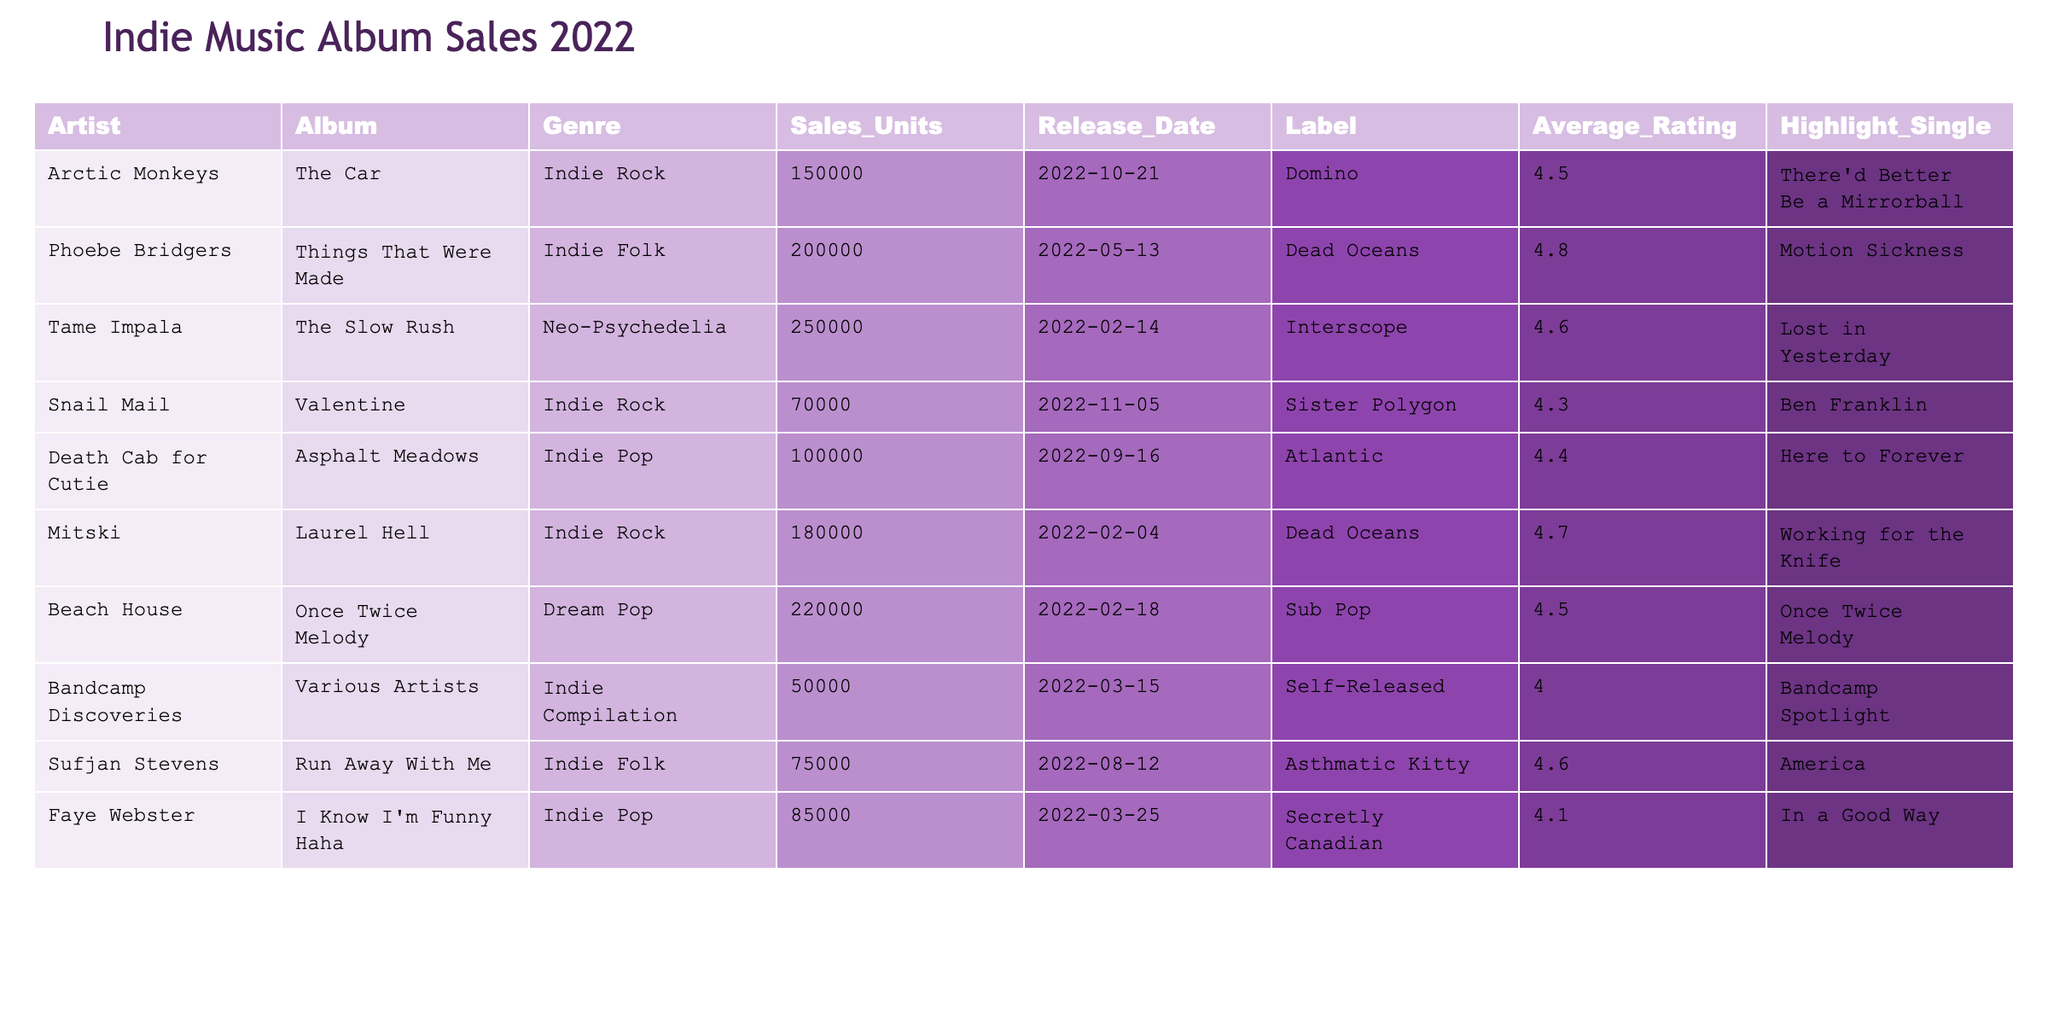What is the total number of sales units for Indie Rock albums? The table shows three Indie Rock albums: "The Car" with 150,000 units, "Valentine" with 70,000 units, and "Laurel Hell" with 180,000 units. To find the total, we add these values: 150,000 + 70,000 + 180,000 = 400,000.
Answer: 400,000 Which album had the highest average rating? The albums are ranked by their average ratings: "Things That Were Made" (4.8), "Laurel Hell" (4.7), "Run Away With Me" (4.6), and so forth. "Things That Were Made" has the highest average rating of 4.8.
Answer: Things That Were Made How many albums were released in 2022? All entries in the table indicate they were released in 2022. Thus, there are a total of 8 albums listed.
Answer: 8 Which genre had the most sales units? To determine this, we need to sum sales units for each genre: Indie Rock (400,000), Indie Folk (275,000), Neo-Psychedelia (250,000), Indie Pop (185,000), Dream Pop (220,000), and Indie Compilation (50,000). Indie Rock has the highest sales at 400,000.
Answer: Indie Rock Is there an album that was both released in November and had an average rating below 4.5? The table shows "Valentine" released in November with a rating of 4.3. Since 4.3 is below 4.5, the statement is true.
Answer: Yes What is the average sales units of albums released by Dead Oceans? The table shows two albums by Dead Oceans: "Things That Were Made" with 200,000 sales units and "Laurel Hell" with 180,000 units. The average is calculated as (200,000 + 180,000) / 2 = 190,000.
Answer: 190,000 How many albums had an average rating of 4.6 or higher? Scanning the table, the albums with ratings of 4.6 or more are "Things That Were Made," "Laurel Hell," "Run Away With Me," and "Lost in Yesterday." This gives a total of 4 albums.
Answer: 4 What is the difference in sales units between the highest and lowest-selling Indie Pop albums? The Indie Pop albums are "Here to Forever" with 100,000 sales and "In a Good Way" with 85,000. The difference is 100,000 - 85,000 = 15,000.
Answer: 15,000 Which artist had an album with the highlight single "America"? The table indicates that Sufjan Stevens' album "Run Away With Me" has the highlight single titled "America."
Answer: Sufjan Stevens Are there any Dream Pop albums with sales above 200,000 units? The table shows "Once Twice Melody," which has sales of 220,000 units, confirming the presence of a Dream Pop album above 200,000 units.
Answer: Yes 